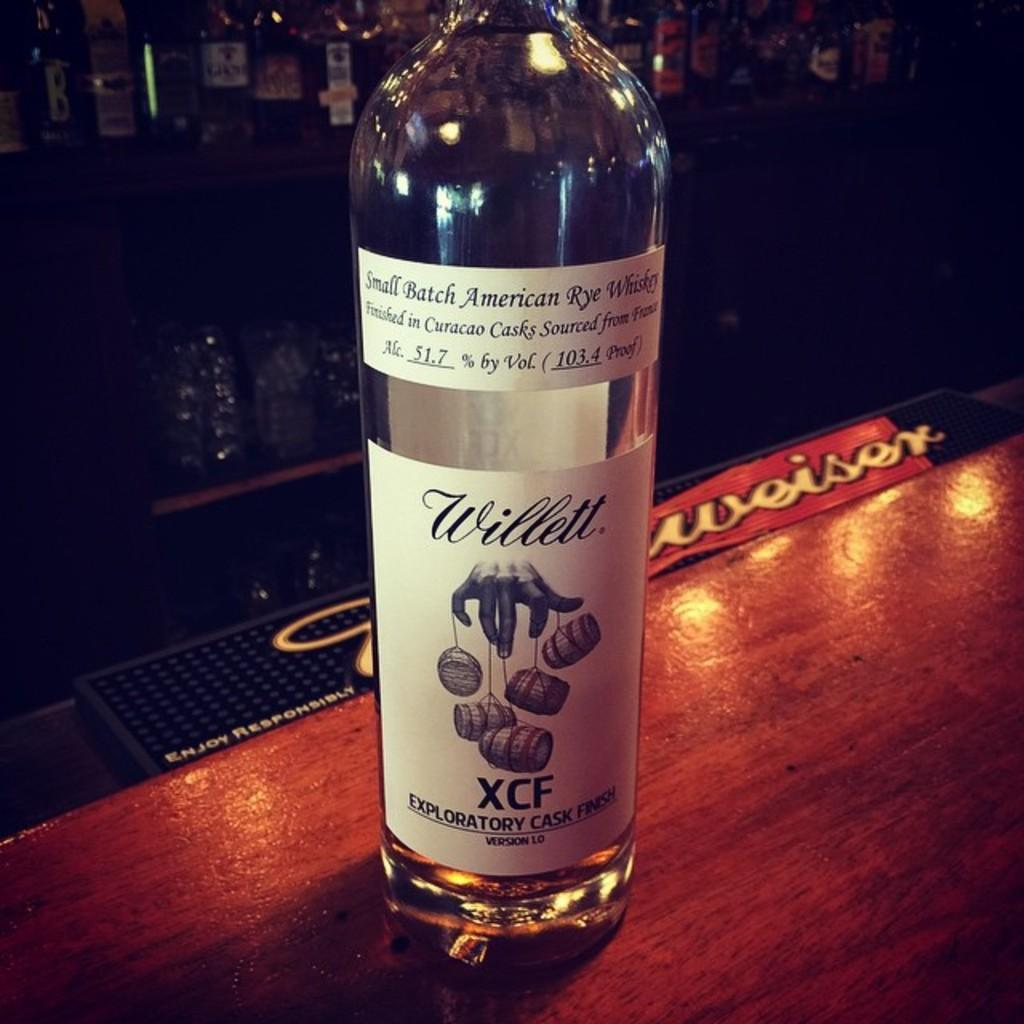Provide a one-sentence caption for the provided image. Large bottle of alcohol named Willett on top of a counter. 